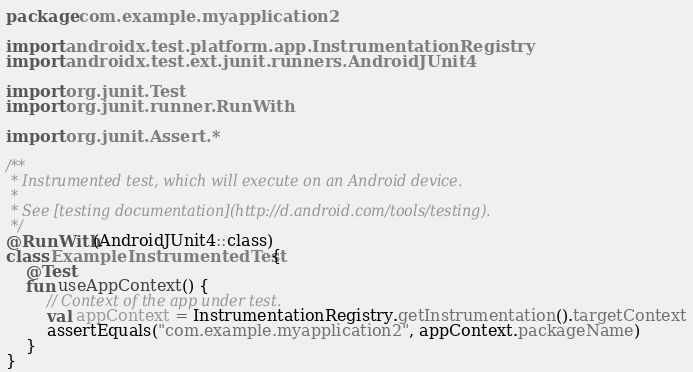<code> <loc_0><loc_0><loc_500><loc_500><_Kotlin_>package com.example.myapplication2

import androidx.test.platform.app.InstrumentationRegistry
import androidx.test.ext.junit.runners.AndroidJUnit4

import org.junit.Test
import org.junit.runner.RunWith

import org.junit.Assert.*

/**
 * Instrumented test, which will execute on an Android device.
 *
 * See [testing documentation](http://d.android.com/tools/testing).
 */
@RunWith(AndroidJUnit4::class)
class ExampleInstrumentedTest {
    @Test
    fun useAppContext() {
        // Context of the app under test.
        val appContext = InstrumentationRegistry.getInstrumentation().targetContext
        assertEquals("com.example.myapplication2", appContext.packageName)
    }
}
</code> 